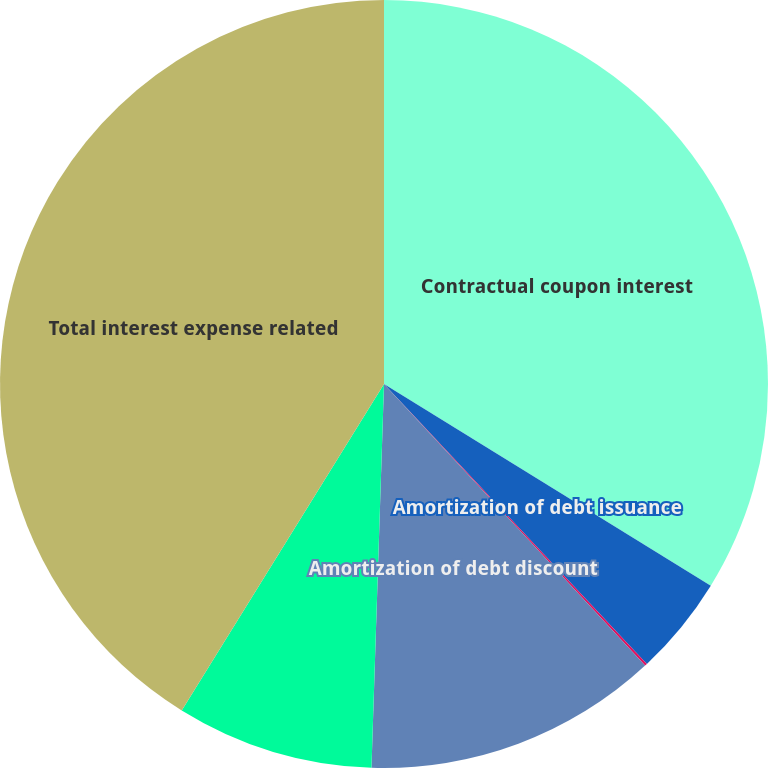Convert chart. <chart><loc_0><loc_0><loc_500><loc_500><pie_chart><fcel>Contractual coupon interest<fcel>Amortization of debt issuance<fcel>Amortization of embedded<fcel>Amortization of debt discount<fcel>Fair value adjustment of<fcel>Total interest expense related<nl><fcel>33.8%<fcel>4.2%<fcel>0.1%<fcel>12.42%<fcel>8.31%<fcel>41.17%<nl></chart> 